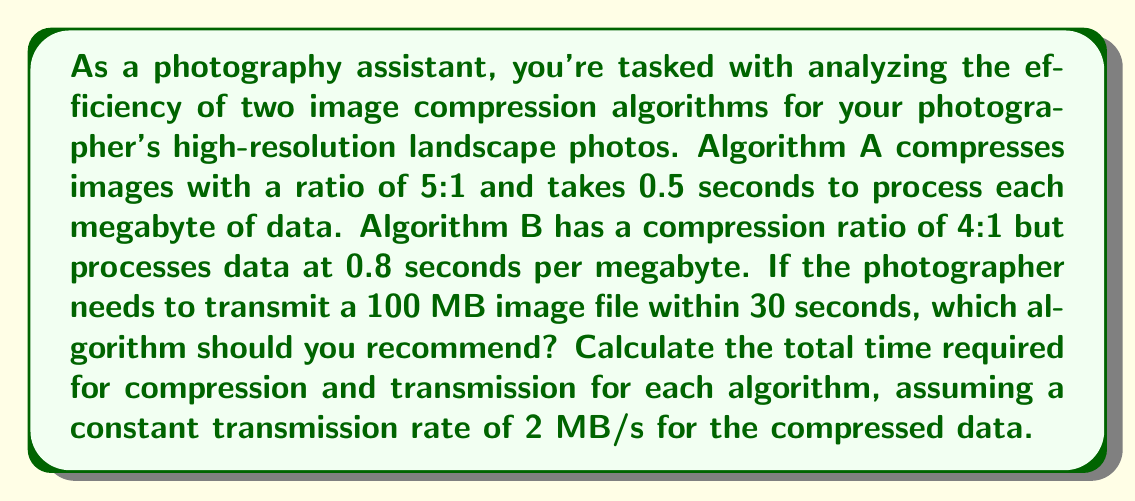Give your solution to this math problem. Let's break this down step-by-step:

1) First, calculate the compressed file size for each algorithm:
   Algorithm A: $100 \text{ MB} \div 5 = 20 \text{ MB}$
   Algorithm B: $100 \text{ MB} \div 4 = 25 \text{ MB}$

2) Calculate the compression time for each algorithm:
   Algorithm A: $100 \text{ MB} \times 0.5 \text{ s/MB} = 50 \text{ s}$
   Algorithm B: $100 \text{ MB} \times 0.8 \text{ s/MB} = 80 \text{ s}$

3) Calculate the transmission time for each compressed file:
   Algorithm A: $20 \text{ MB} \div 2 \text{ MB/s} = 10 \text{ s}$
   Algorithm B: $25 \text{ MB} \div 2 \text{ MB/s} = 12.5 \text{ s}$

4) Calculate the total time (compression + transmission) for each algorithm:
   Algorithm A: $50 \text{ s} + 10 \text{ s} = 60 \text{ s}$
   Algorithm B: $80 \text{ s} + 12.5 \text{ s} = 92.5 \text{ s}$

5) Compare the total times to the 30-second requirement:
   Neither algorithm meets the 30-second requirement. However, Algorithm A is faster overall.
Answer: Algorithm A should be recommended. Although neither algorithm meets the 30-second requirement, Algorithm A is more efficient with a total processing and transmission time of 60 seconds, compared to 92.5 seconds for Algorithm B. 